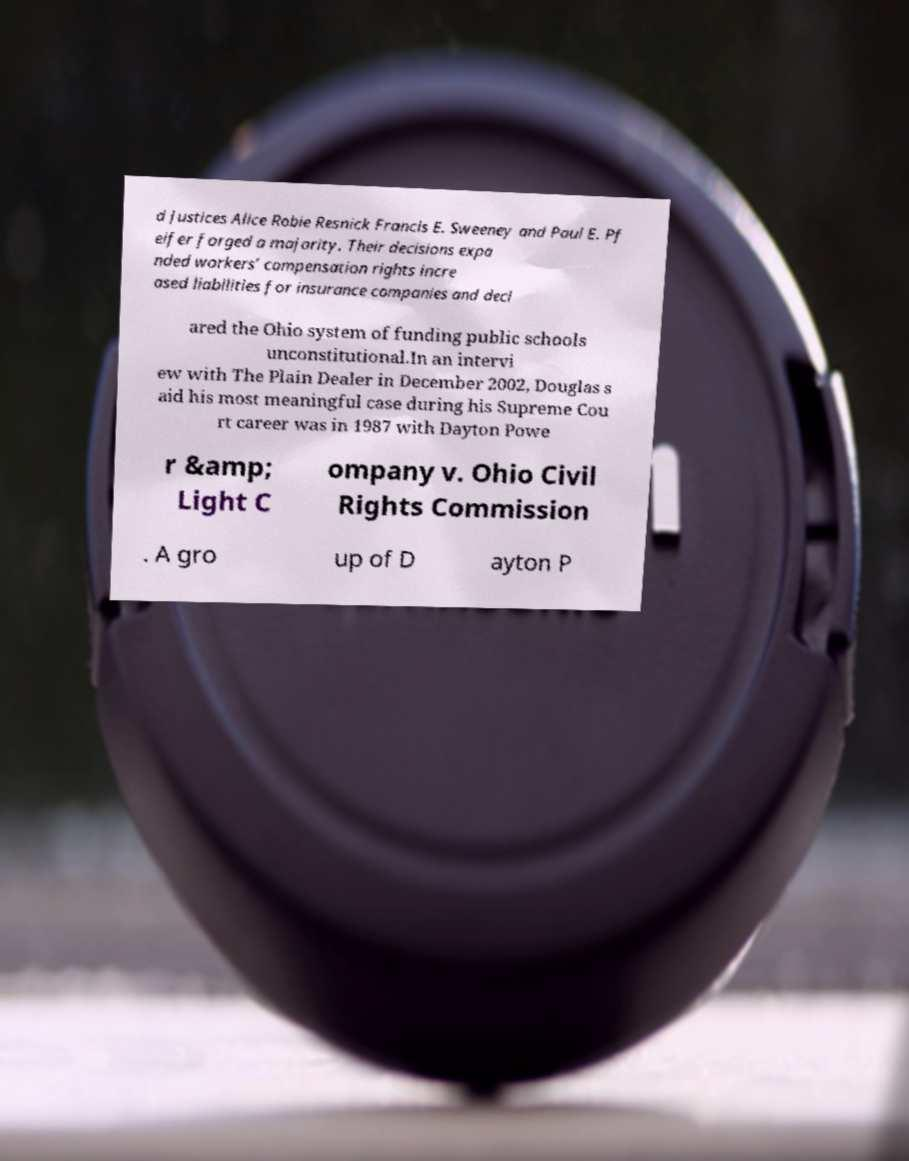I need the written content from this picture converted into text. Can you do that? d Justices Alice Robie Resnick Francis E. Sweeney and Paul E. Pf eifer forged a majority. Their decisions expa nded workers’ compensation rights incre ased liabilities for insurance companies and decl ared the Ohio system of funding public schools unconstitutional.In an intervi ew with The Plain Dealer in December 2002, Douglas s aid his most meaningful case during his Supreme Cou rt career was in 1987 with Dayton Powe r &amp; Light C ompany v. Ohio Civil Rights Commission . A gro up of D ayton P 